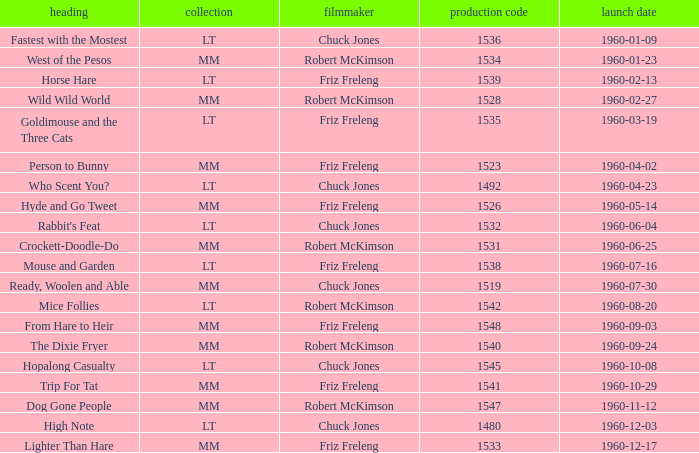What is the Series number of the episode with a production number of 1547? MM. 